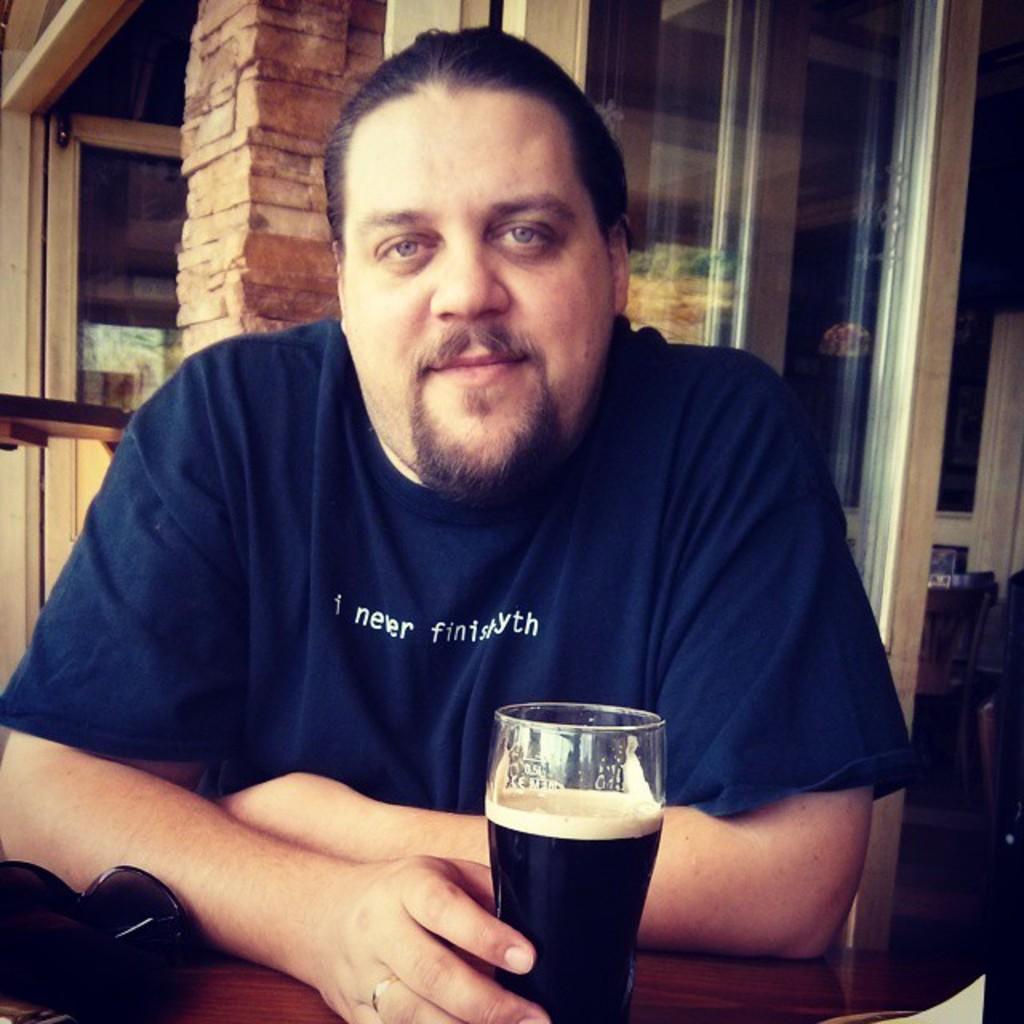In one or two sentences, can you explain what this image depicts? In this picture we can see man sitting on chair and holding glass with drink in it in his hand and he is smiling and in background we can see pillar, doors, windows. 